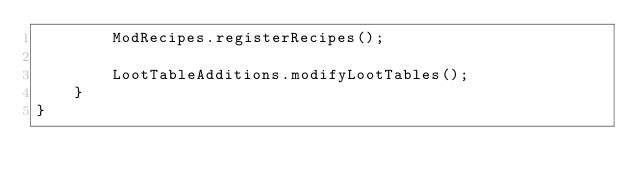Convert code to text. <code><loc_0><loc_0><loc_500><loc_500><_Java_>        ModRecipes.registerRecipes();

        LootTableAdditions.modifyLootTables();
    }
}
</code> 